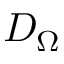<formula> <loc_0><loc_0><loc_500><loc_500>D _ { \Omega }</formula> 